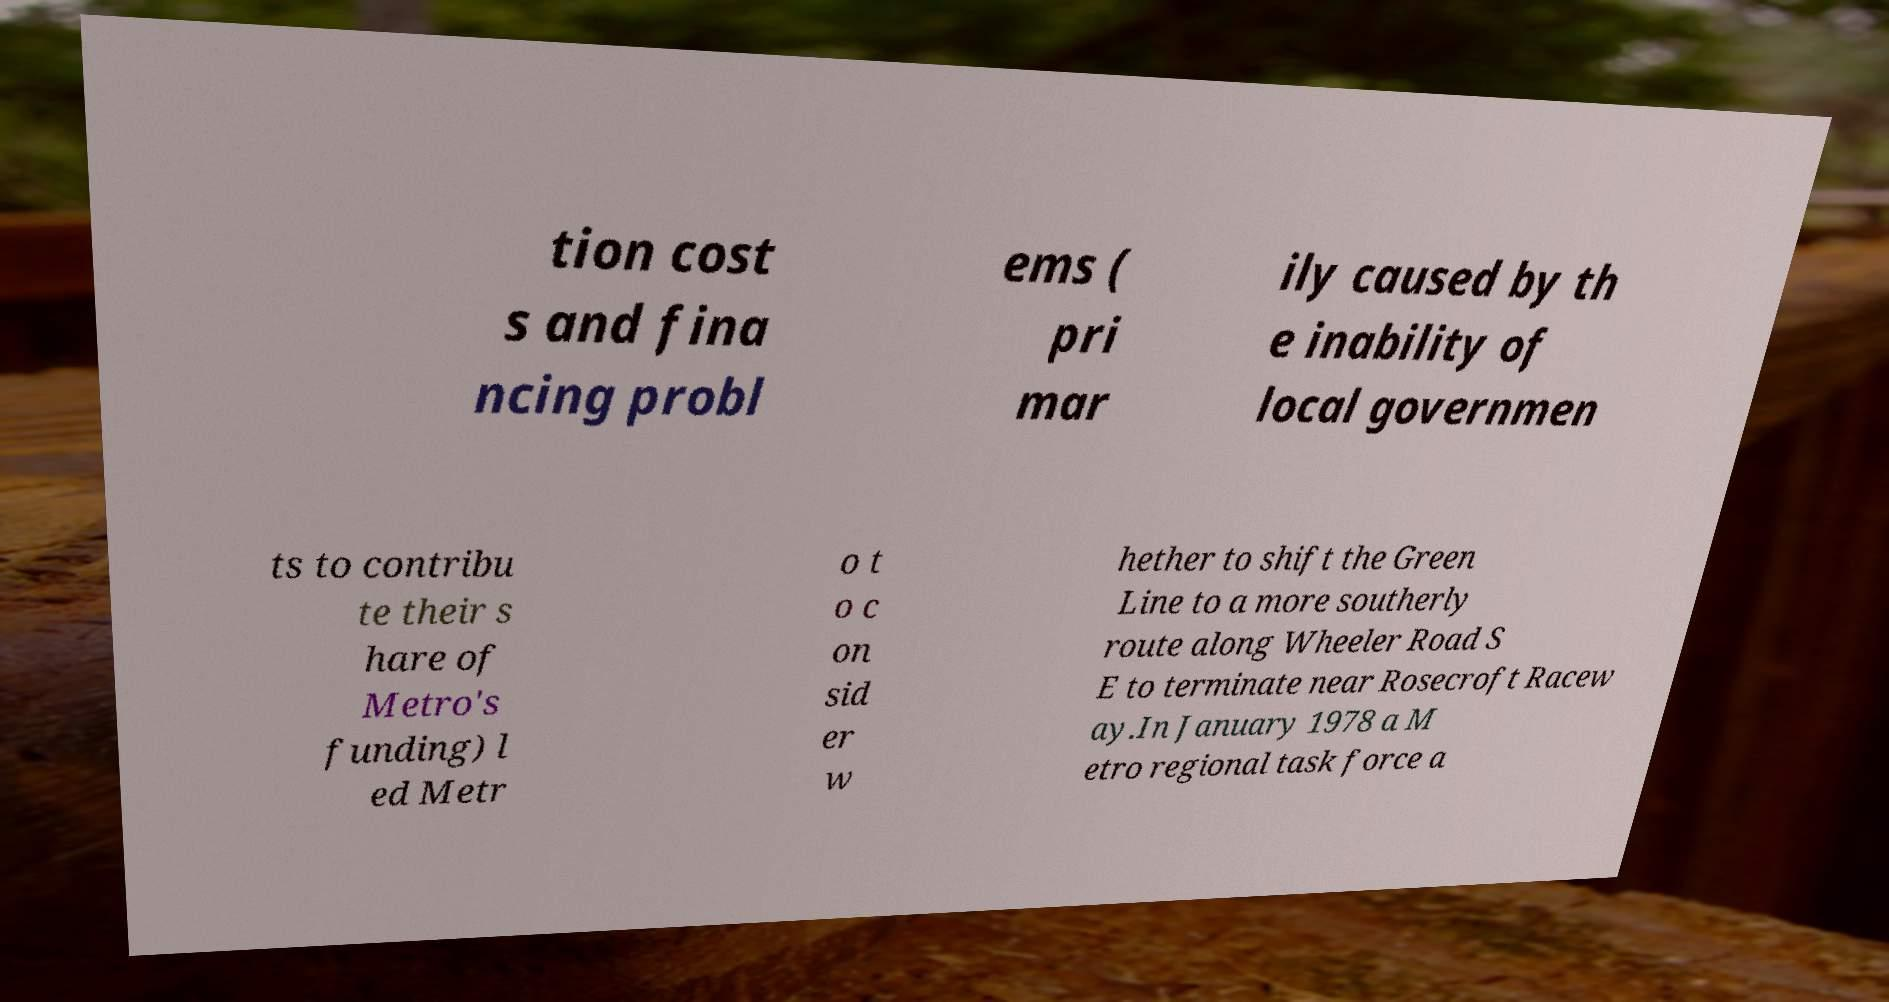For documentation purposes, I need the text within this image transcribed. Could you provide that? tion cost s and fina ncing probl ems ( pri mar ily caused by th e inability of local governmen ts to contribu te their s hare of Metro's funding) l ed Metr o t o c on sid er w hether to shift the Green Line to a more southerly route along Wheeler Road S E to terminate near Rosecroft Racew ay.In January 1978 a M etro regional task force a 